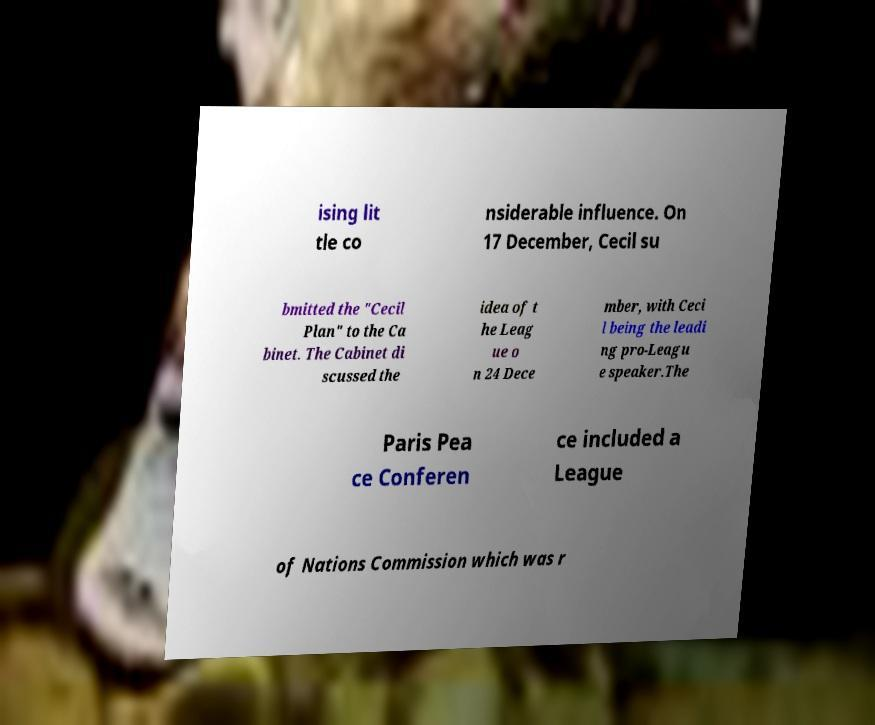Please read and relay the text visible in this image. What does it say? ising lit tle co nsiderable influence. On 17 December, Cecil su bmitted the "Cecil Plan" to the Ca binet. The Cabinet di scussed the idea of t he Leag ue o n 24 Dece mber, with Ceci l being the leadi ng pro-Leagu e speaker.The Paris Pea ce Conferen ce included a League of Nations Commission which was r 